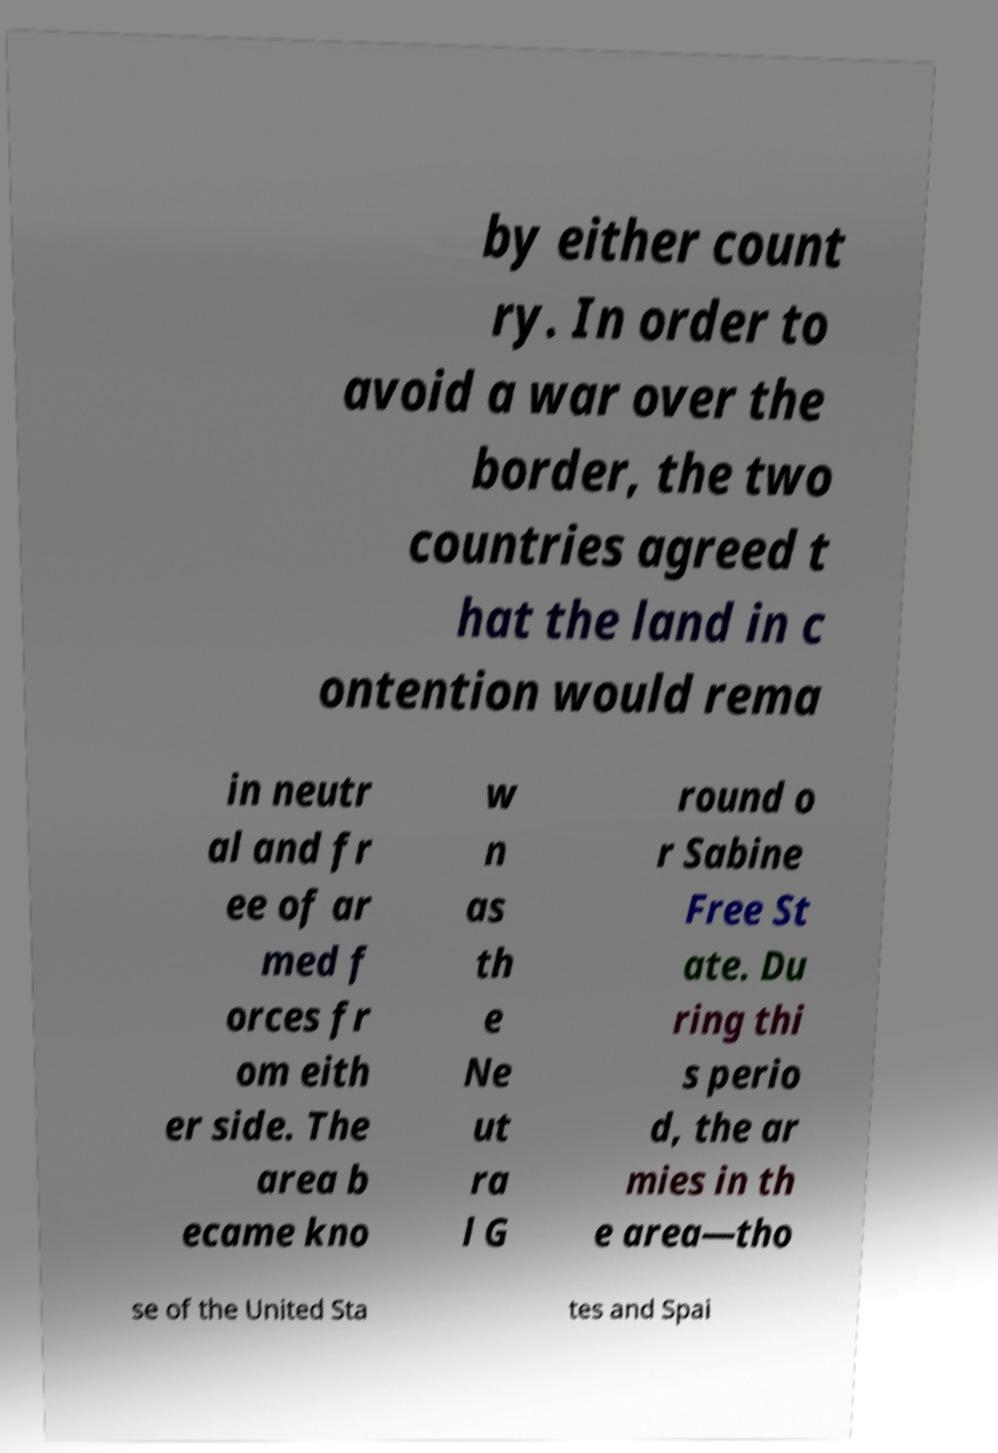What messages or text are displayed in this image? I need them in a readable, typed format. by either count ry. In order to avoid a war over the border, the two countries agreed t hat the land in c ontention would rema in neutr al and fr ee of ar med f orces fr om eith er side. The area b ecame kno w n as th e Ne ut ra l G round o r Sabine Free St ate. Du ring thi s perio d, the ar mies in th e area—tho se of the United Sta tes and Spai 